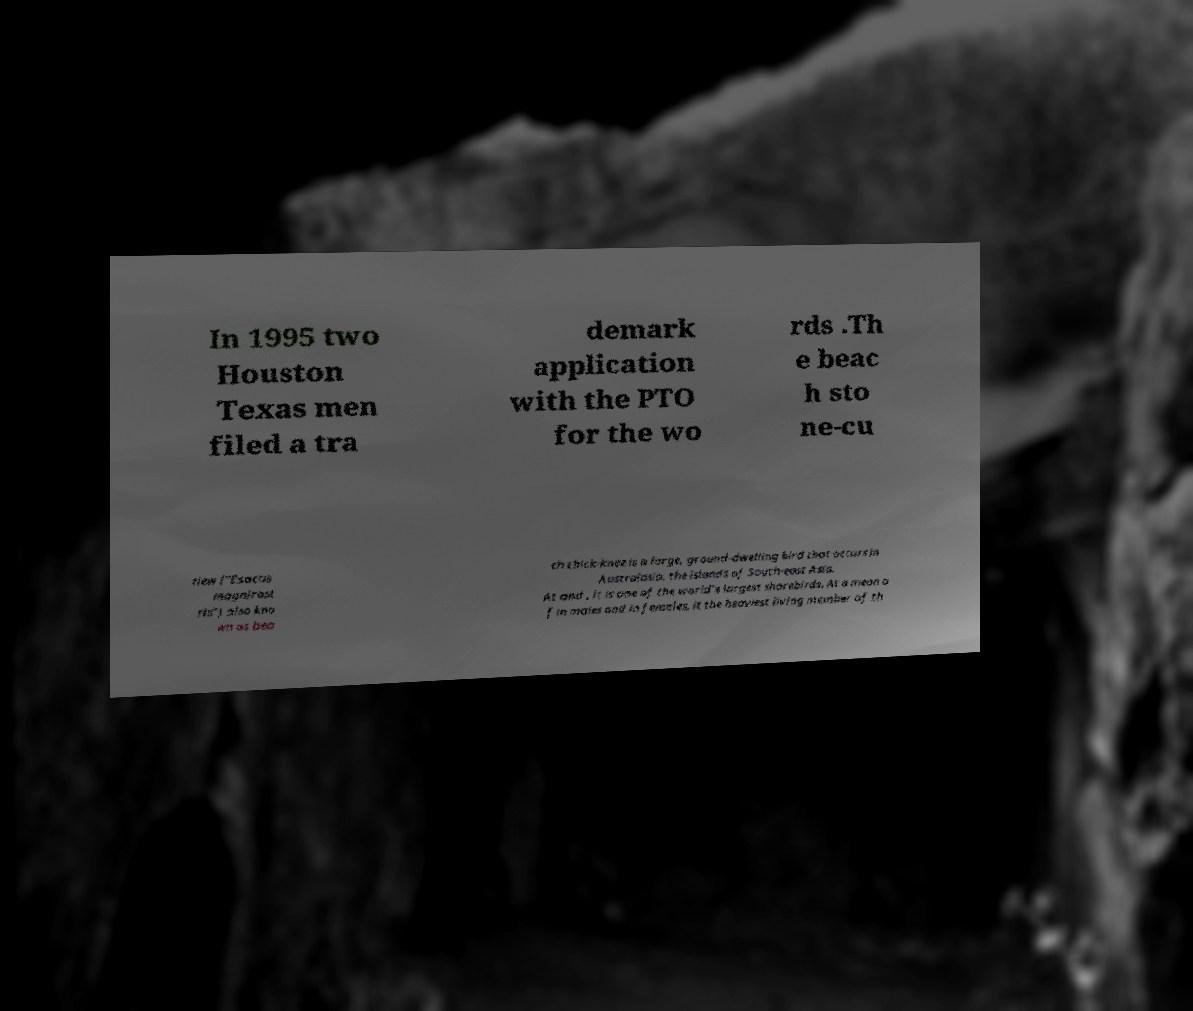Please identify and transcribe the text found in this image. In 1995 two Houston Texas men filed a tra demark application with the PTO for the wo rds .Th e beac h sto ne-cu rlew ("Esacus magnirost ris") also kno wn as bea ch thick-knee is a large, ground-dwelling bird that occurs in Australasia, the islands of South-east Asia. At and , it is one of the world's largest shorebirds. At a mean o f in males and in females, it the heaviest living member of th 